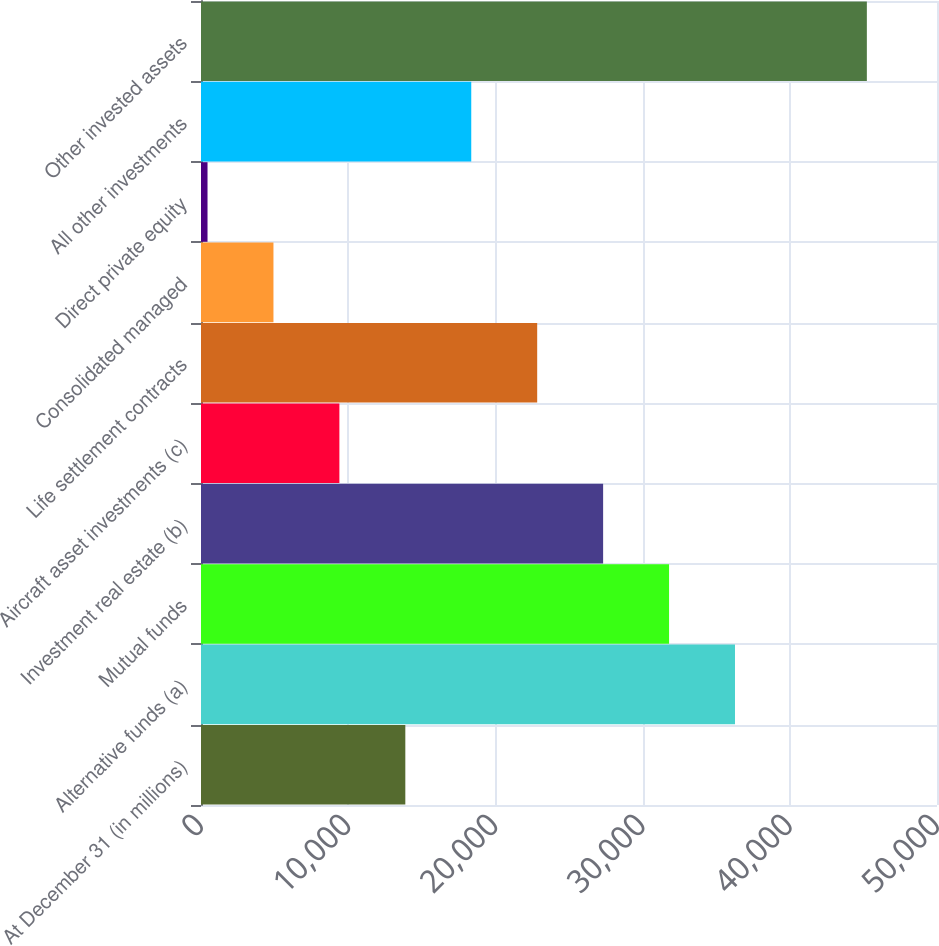<chart> <loc_0><loc_0><loc_500><loc_500><bar_chart><fcel>At December 31 (in millions)<fcel>Alternative funds (a)<fcel>Mutual funds<fcel>Investment real estate (b)<fcel>Aircraft asset investments (c)<fcel>Life settlement contracts<fcel>Consolidated managed<fcel>Direct private equity<fcel>All other investments<fcel>Other invested assets<nl><fcel>13880.6<fcel>36276.6<fcel>31797.4<fcel>27318.2<fcel>9401.4<fcel>22839<fcel>4922.2<fcel>443<fcel>18359.8<fcel>45235<nl></chart> 